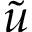Convert formula to latex. <formula><loc_0><loc_0><loc_500><loc_500>\tilde { u }</formula> 